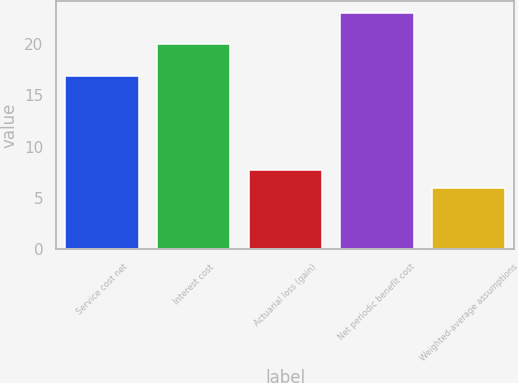<chart> <loc_0><loc_0><loc_500><loc_500><bar_chart><fcel>Service cost net<fcel>Interest cost<fcel>Actuarial loss (gain)<fcel>Net periodic benefit cost<fcel>Weighted-average assumptions<nl><fcel>16.9<fcel>20<fcel>7.7<fcel>23<fcel>6<nl></chart> 